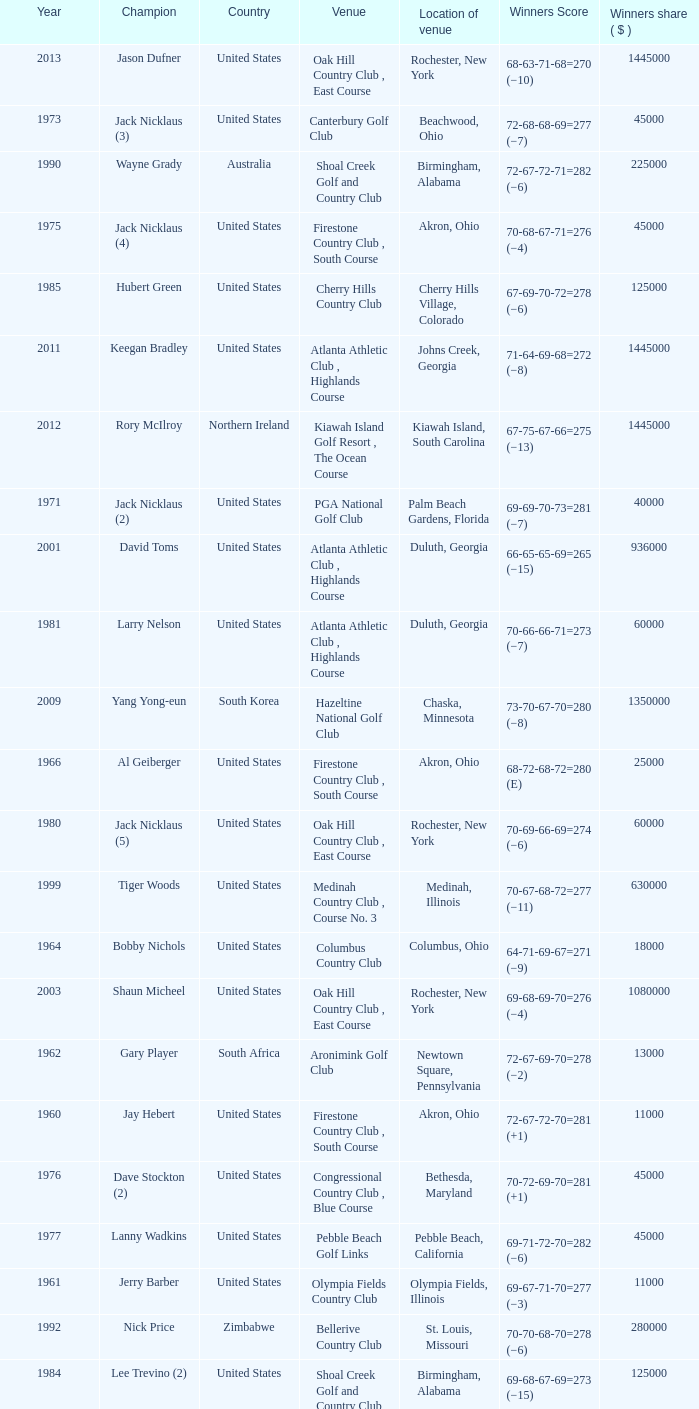Where is the Bellerive Country Club venue located? St. Louis, Missouri. 